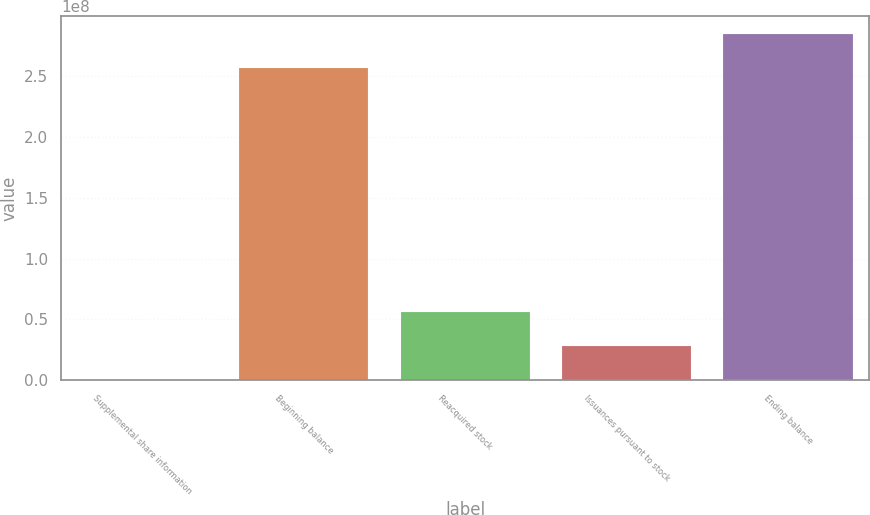Convert chart. <chart><loc_0><loc_0><loc_500><loc_500><bar_chart><fcel>Supplemental share information<fcel>Beginning balance<fcel>Reacquired stock<fcel>Issuances pursuant to stock<fcel>Ending balance<nl><fcel>2013<fcel>2.56941e+08<fcel>5.6149e+07<fcel>2.80755e+07<fcel>2.85015e+08<nl></chart> 